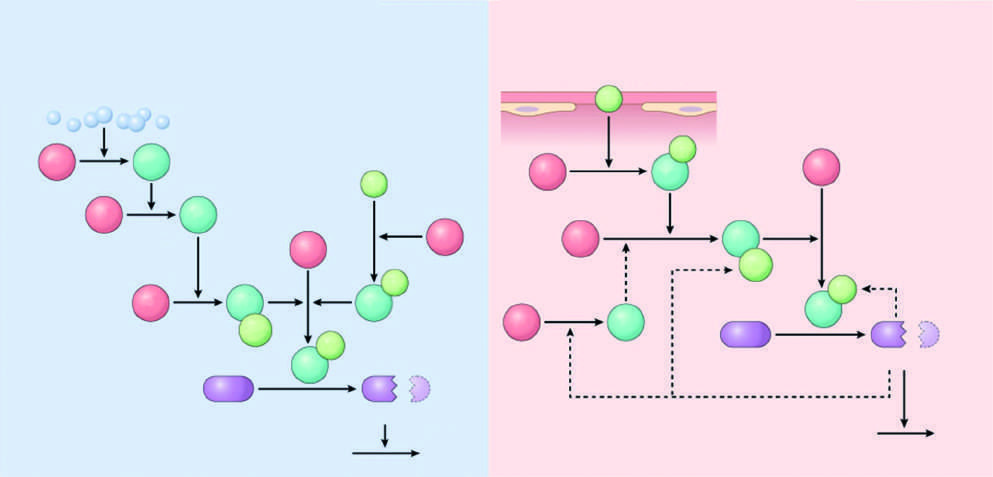re the red polypeptides inactive factors?
Answer the question using a single word or phrase. Yes 